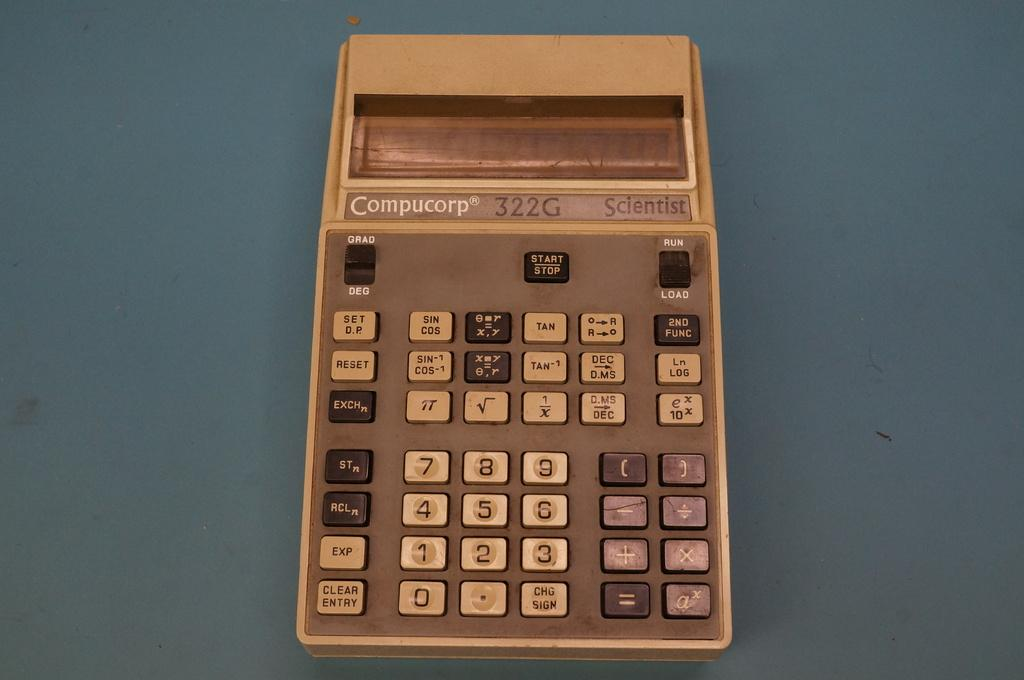<image>
Relay a brief, clear account of the picture shown. An old Compucorp calculator has a plain digital readout display. 